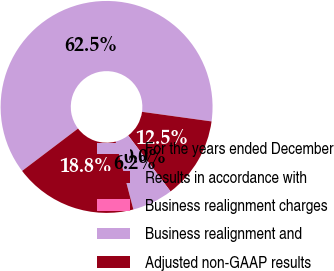<chart> <loc_0><loc_0><loc_500><loc_500><pie_chart><fcel>For the years ended December<fcel>Results in accordance with<fcel>Business realignment charges<fcel>Business realignment and<fcel>Adjusted non-GAAP results<nl><fcel>62.5%<fcel>12.5%<fcel>0.0%<fcel>6.25%<fcel>18.75%<nl></chart> 